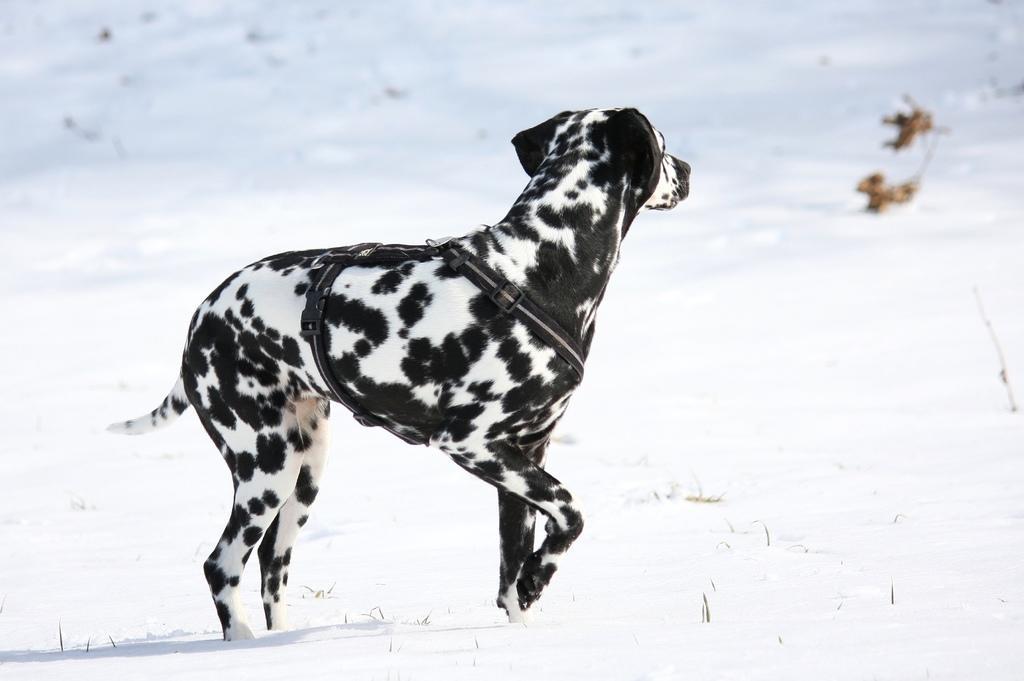Could you give a brief overview of what you see in this image? In the picture I can see a dalmatian dog with a belt is standing on the snow. The background of the image is blurred. 